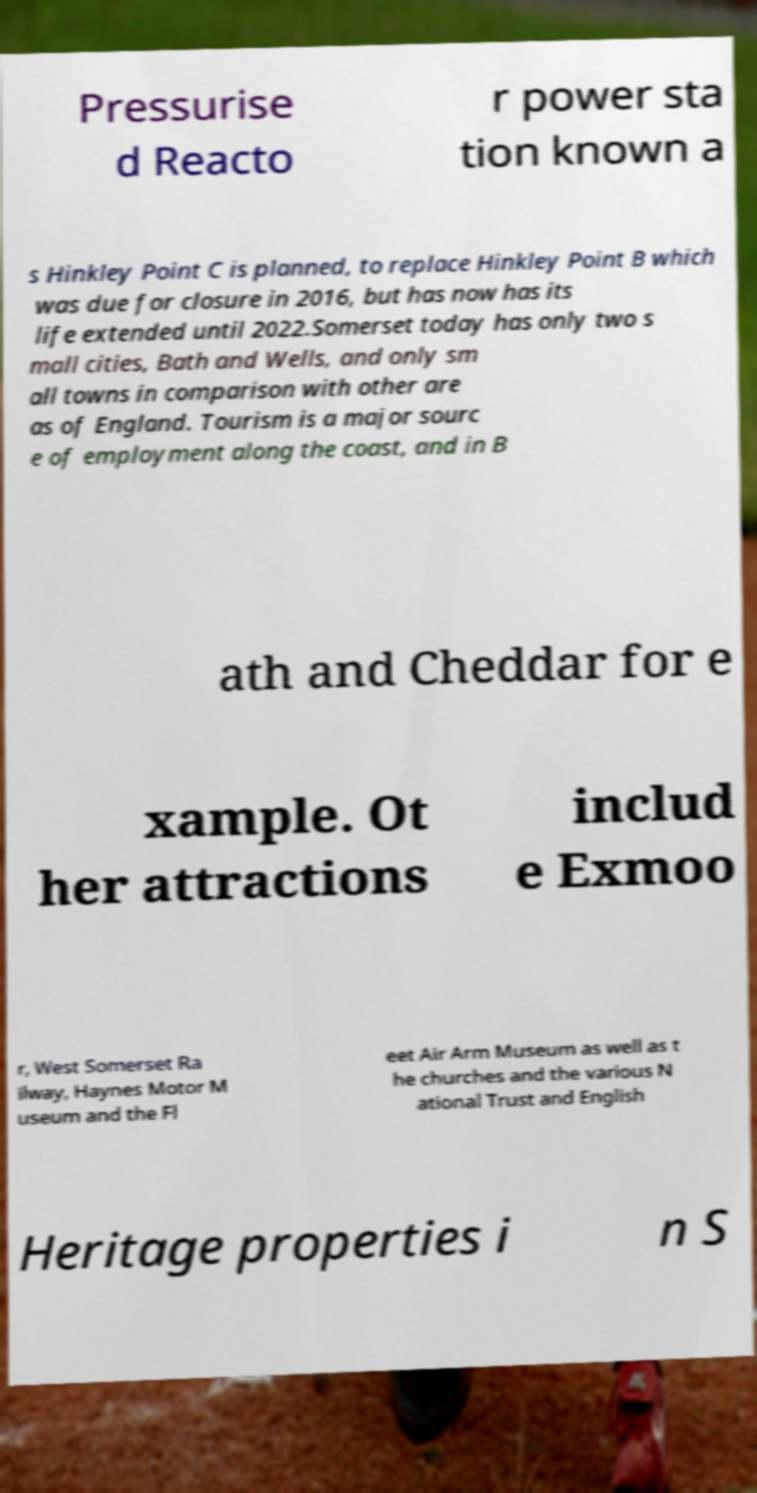Could you assist in decoding the text presented in this image and type it out clearly? Pressurise d Reacto r power sta tion known a s Hinkley Point C is planned, to replace Hinkley Point B which was due for closure in 2016, but has now has its life extended until 2022.Somerset today has only two s mall cities, Bath and Wells, and only sm all towns in comparison with other are as of England. Tourism is a major sourc e of employment along the coast, and in B ath and Cheddar for e xample. Ot her attractions includ e Exmoo r, West Somerset Ra ilway, Haynes Motor M useum and the Fl eet Air Arm Museum as well as t he churches and the various N ational Trust and English Heritage properties i n S 